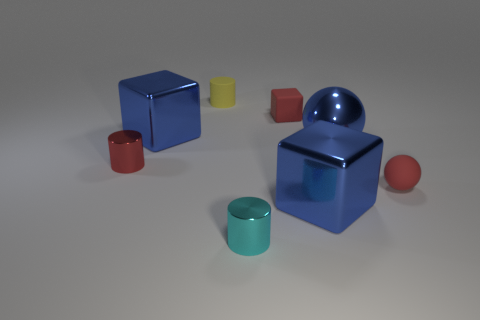How many objects are there in total, and can you describe their shapes? There are six objects in total. Starting from the left, there's a blue cube, a small yellow cylinder, a red cylinder, a large blue cube, a cyan cylinder, and a red sphere. Their shapes are basic geometric forms, which offer a clear view into primary 3D shapes. 